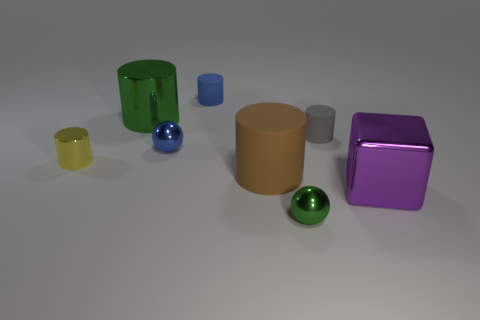There is a gray matte object; is it the same shape as the green thing in front of the tiny yellow shiny thing?
Keep it short and to the point. No. How many matte objects are either small purple blocks or tiny green balls?
Ensure brevity in your answer.  0. There is a rubber object that is on the right side of the small ball that is in front of the big cylinder that is right of the green cylinder; what is its color?
Keep it short and to the point. Gray. What number of other objects are the same material as the large brown cylinder?
Your answer should be very brief. 2. There is a blue matte thing that is right of the big green thing; is it the same shape as the large purple metallic thing?
Offer a terse response. No. What number of tiny things are either metallic cylinders or blue matte spheres?
Your answer should be compact. 1. Are there the same number of large brown matte things that are left of the blue cylinder and brown cylinders behind the small gray cylinder?
Your response must be concise. Yes. What number of other things are the same color as the big shiny block?
Provide a short and direct response. 0. Is the color of the large rubber object the same as the tiny matte thing on the left side of the gray rubber object?
Provide a short and direct response. No. How many brown objects are rubber cylinders or large rubber cylinders?
Make the answer very short. 1. 